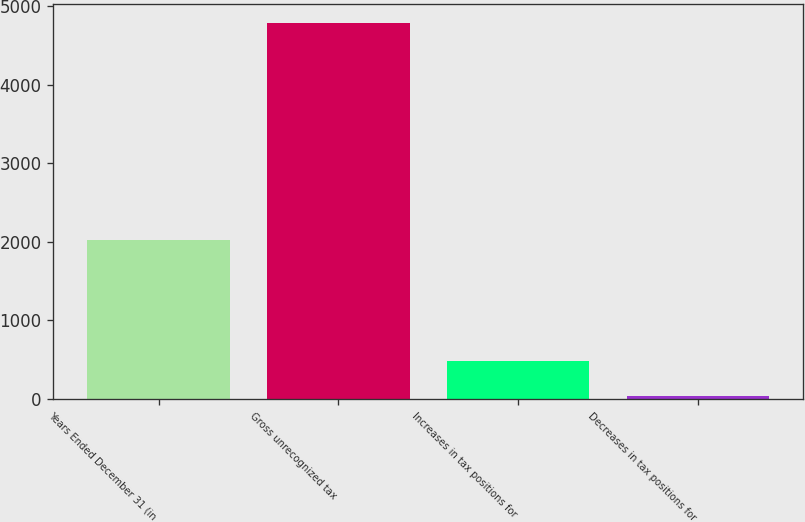Convert chart to OTSL. <chart><loc_0><loc_0><loc_500><loc_500><bar_chart><fcel>Years Ended December 31 (in<fcel>Gross unrecognized tax<fcel>Increases in tax positions for<fcel>Decreases in tax positions for<nl><fcel>2016<fcel>4780.1<fcel>488.1<fcel>39<nl></chart> 